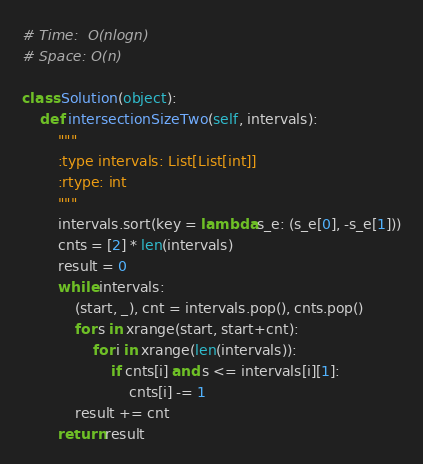Convert code to text. <code><loc_0><loc_0><loc_500><loc_500><_Python_># Time:  O(nlogn)
# Space: O(n)

class Solution(object):
    def intersectionSizeTwo(self, intervals):
        """
        :type intervals: List[List[int]]
        :rtype: int
        """
        intervals.sort(key = lambda s_e: (s_e[0], -s_e[1]))
        cnts = [2] * len(intervals)
        result = 0
        while intervals:
            (start, _), cnt = intervals.pop(), cnts.pop()
            for s in xrange(start, start+cnt):
                for i in xrange(len(intervals)):
                    if cnts[i] and s <= intervals[i][1]:
                        cnts[i] -= 1
            result += cnt
        return result

</code> 